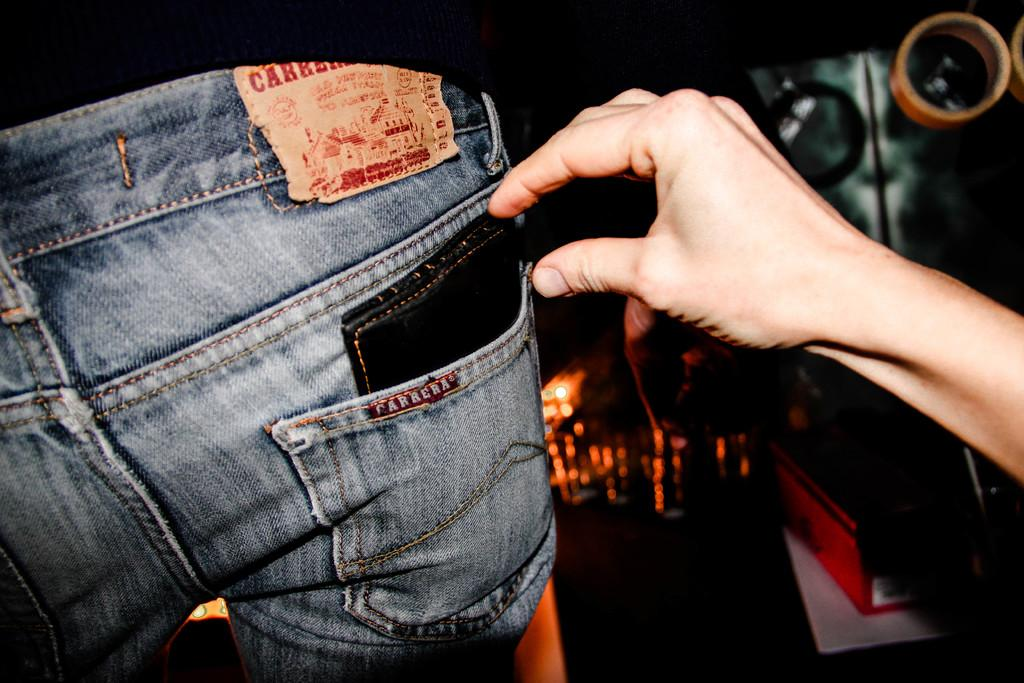What is located inside a jeans pocket in the image? There is a purse in a jeans pocket of a person in the image. What part of the person's body is visible near the purse? A person's hand is visible beside the purse. Can you describe the background of the image? The background of the image contains some objects. How would you describe the overall appearance of the image? The image has a dark appearance. What type of soap is being used to wash the dinner dishes in the image? There is no soap, dinner dishes, or any indication of a dinner scene in the image. 